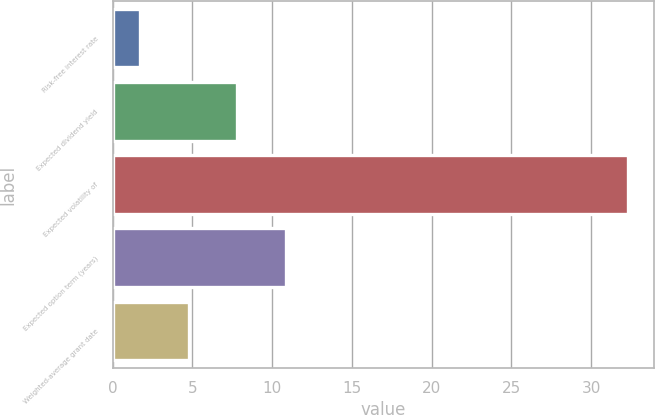<chart> <loc_0><loc_0><loc_500><loc_500><bar_chart><fcel>Risk-free interest rate<fcel>Expected dividend yield<fcel>Expected volatility of<fcel>Expected option term (years)<fcel>Weighted-average grant date<nl><fcel>1.69<fcel>7.81<fcel>32.3<fcel>10.87<fcel>4.75<nl></chart> 